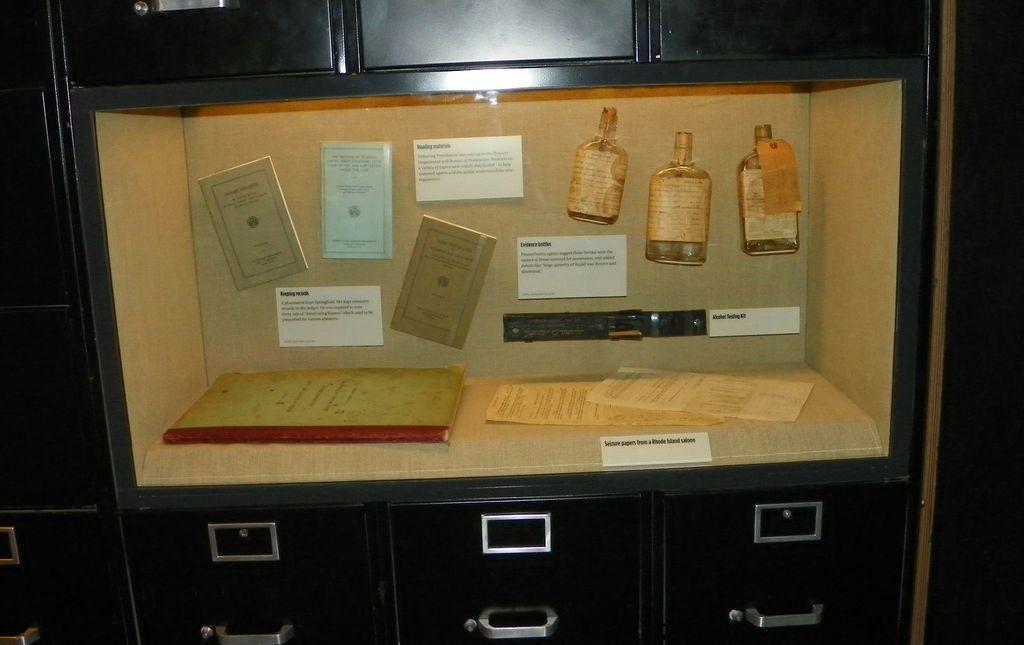Describe this image in one or two sentences. In the picture we can see cupboards which are black in color and in the middle of it, we can see a rack which is cream in color, in it we can see some cards with some information posted in the rack and in the rack we can see a book and some papers with some information in it. 